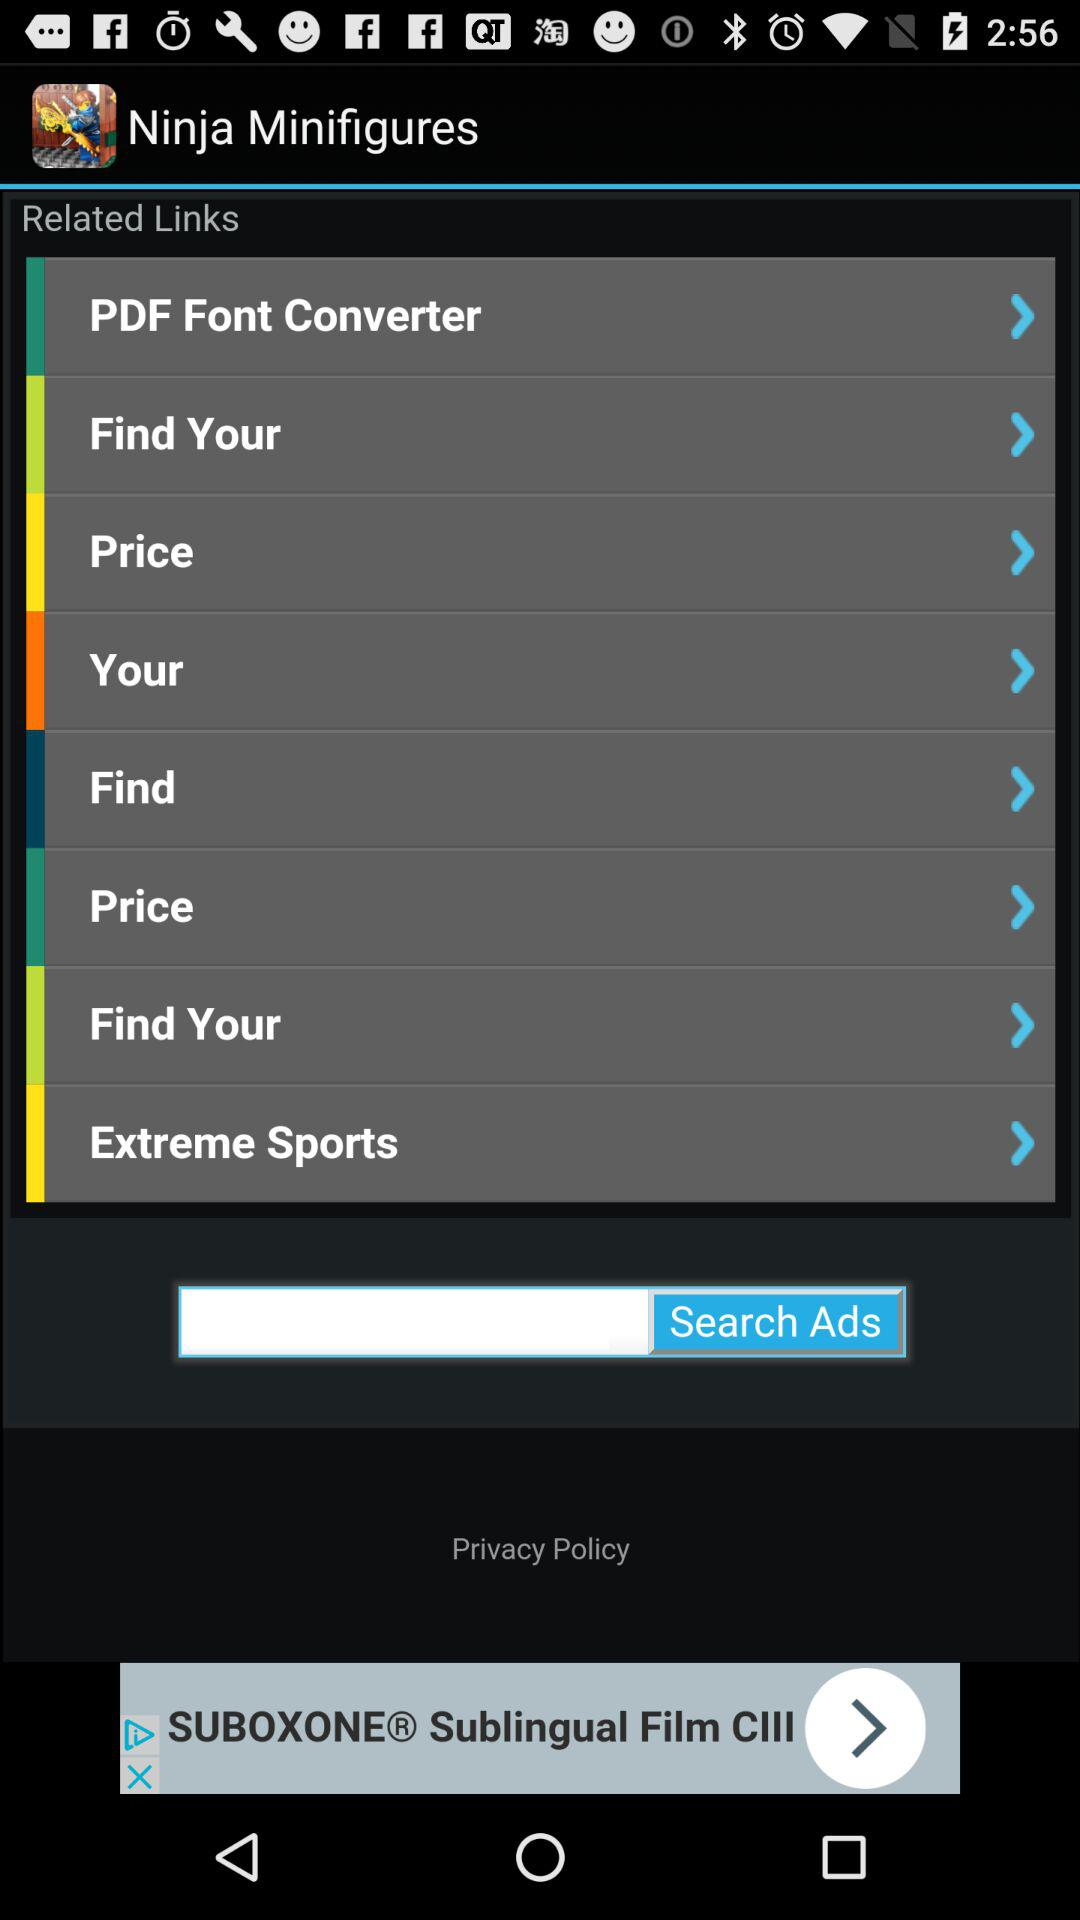What is the name of the application? The name of the application is "Ninja Minifigures". 